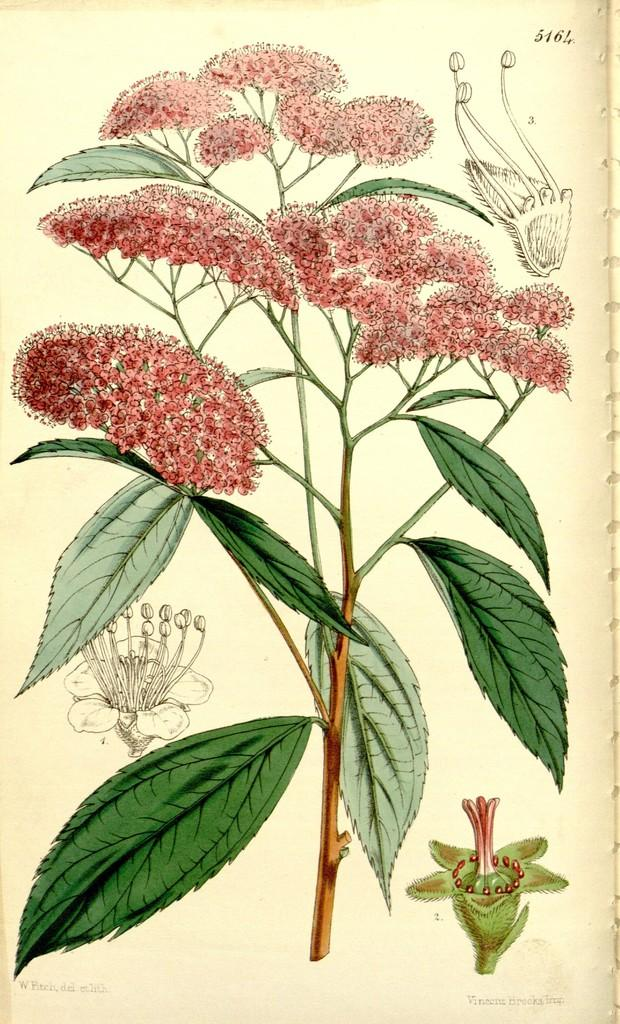What is depicted in the image? There is an art of a plant in the image. Can you describe the plant in the image? The plant has leaves and flowers. How does the icicle affect the acoustics of the plant in the image? There is no icicle present in the image, and therefore it cannot affect the acoustics of the plant. 